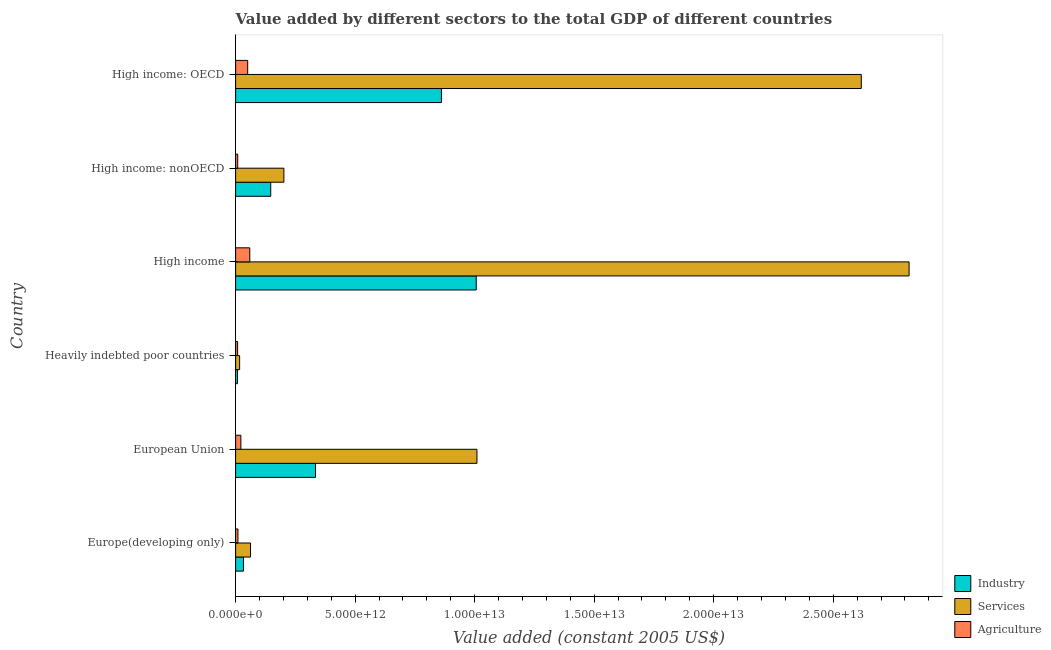How many different coloured bars are there?
Ensure brevity in your answer.  3. How many groups of bars are there?
Your answer should be very brief. 6. Are the number of bars per tick equal to the number of legend labels?
Make the answer very short. Yes. What is the label of the 5th group of bars from the top?
Keep it short and to the point. European Union. What is the value added by agricultural sector in High income: OECD?
Provide a short and direct response. 5.05e+11. Across all countries, what is the maximum value added by agricultural sector?
Ensure brevity in your answer.  5.92e+11. Across all countries, what is the minimum value added by services?
Provide a succinct answer. 1.68e+11. In which country was the value added by industrial sector minimum?
Offer a terse response. Heavily indebted poor countries. What is the total value added by agricultural sector in the graph?
Make the answer very short. 1.58e+12. What is the difference between the value added by services in European Union and that in High income: OECD?
Offer a terse response. -1.61e+13. What is the difference between the value added by industrial sector in High income and the value added by agricultural sector in European Union?
Keep it short and to the point. 9.85e+12. What is the average value added by industrial sector per country?
Give a very brief answer. 3.98e+12. What is the difference between the value added by agricultural sector and value added by services in High income?
Make the answer very short. -2.76e+13. What is the ratio of the value added by industrial sector in Heavily indebted poor countries to that in High income: nonOECD?
Ensure brevity in your answer.  0.05. Is the value added by industrial sector in European Union less than that in High income?
Offer a terse response. Yes. Is the difference between the value added by agricultural sector in Europe(developing only) and High income: nonOECD greater than the difference between the value added by industrial sector in Europe(developing only) and High income: nonOECD?
Provide a short and direct response. Yes. What is the difference between the highest and the second highest value added by agricultural sector?
Offer a very short reply. 8.76e+1. What is the difference between the highest and the lowest value added by industrial sector?
Keep it short and to the point. 9.99e+12. Is the sum of the value added by services in European Union and High income: nonOECD greater than the maximum value added by agricultural sector across all countries?
Give a very brief answer. Yes. What does the 1st bar from the top in High income: nonOECD represents?
Provide a short and direct response. Agriculture. What does the 1st bar from the bottom in High income represents?
Your response must be concise. Industry. Is it the case that in every country, the sum of the value added by industrial sector and value added by services is greater than the value added by agricultural sector?
Your response must be concise. Yes. How many bars are there?
Your response must be concise. 18. Are all the bars in the graph horizontal?
Provide a short and direct response. Yes. How many countries are there in the graph?
Your answer should be very brief. 6. What is the difference between two consecutive major ticks on the X-axis?
Ensure brevity in your answer.  5.00e+12. Are the values on the major ticks of X-axis written in scientific E-notation?
Offer a very short reply. Yes. Does the graph contain any zero values?
Keep it short and to the point. No. Does the graph contain grids?
Ensure brevity in your answer.  No. Where does the legend appear in the graph?
Ensure brevity in your answer.  Bottom right. How are the legend labels stacked?
Offer a very short reply. Vertical. What is the title of the graph?
Make the answer very short. Value added by different sectors to the total GDP of different countries. What is the label or title of the X-axis?
Keep it short and to the point. Value added (constant 2005 US$). What is the Value added (constant 2005 US$) of Industry in Europe(developing only)?
Give a very brief answer. 3.29e+11. What is the Value added (constant 2005 US$) in Services in Europe(developing only)?
Make the answer very short. 6.24e+11. What is the Value added (constant 2005 US$) of Agriculture in Europe(developing only)?
Your answer should be very brief. 9.71e+1. What is the Value added (constant 2005 US$) in Industry in European Union?
Give a very brief answer. 3.34e+12. What is the Value added (constant 2005 US$) of Services in European Union?
Ensure brevity in your answer.  1.01e+13. What is the Value added (constant 2005 US$) of Agriculture in European Union?
Your answer should be compact. 2.20e+11. What is the Value added (constant 2005 US$) in Industry in Heavily indebted poor countries?
Give a very brief answer. 7.92e+1. What is the Value added (constant 2005 US$) of Services in Heavily indebted poor countries?
Provide a short and direct response. 1.68e+11. What is the Value added (constant 2005 US$) in Agriculture in Heavily indebted poor countries?
Make the answer very short. 8.35e+1. What is the Value added (constant 2005 US$) of Industry in High income?
Ensure brevity in your answer.  1.01e+13. What is the Value added (constant 2005 US$) in Services in High income?
Offer a very short reply. 2.82e+13. What is the Value added (constant 2005 US$) of Agriculture in High income?
Give a very brief answer. 5.92e+11. What is the Value added (constant 2005 US$) in Industry in High income: nonOECD?
Your response must be concise. 1.47e+12. What is the Value added (constant 2005 US$) of Services in High income: nonOECD?
Your answer should be compact. 2.02e+12. What is the Value added (constant 2005 US$) of Agriculture in High income: nonOECD?
Offer a very short reply. 8.76e+1. What is the Value added (constant 2005 US$) in Industry in High income: OECD?
Provide a short and direct response. 8.61e+12. What is the Value added (constant 2005 US$) of Services in High income: OECD?
Give a very brief answer. 2.62e+13. What is the Value added (constant 2005 US$) of Agriculture in High income: OECD?
Your answer should be very brief. 5.05e+11. Across all countries, what is the maximum Value added (constant 2005 US$) in Industry?
Offer a terse response. 1.01e+13. Across all countries, what is the maximum Value added (constant 2005 US$) of Services?
Your response must be concise. 2.82e+13. Across all countries, what is the maximum Value added (constant 2005 US$) in Agriculture?
Provide a short and direct response. 5.92e+11. Across all countries, what is the minimum Value added (constant 2005 US$) of Industry?
Provide a succinct answer. 7.92e+1. Across all countries, what is the minimum Value added (constant 2005 US$) in Services?
Your response must be concise. 1.68e+11. Across all countries, what is the minimum Value added (constant 2005 US$) in Agriculture?
Offer a very short reply. 8.35e+1. What is the total Value added (constant 2005 US$) of Industry in the graph?
Give a very brief answer. 2.39e+13. What is the total Value added (constant 2005 US$) in Services in the graph?
Offer a terse response. 6.73e+13. What is the total Value added (constant 2005 US$) of Agriculture in the graph?
Ensure brevity in your answer.  1.58e+12. What is the difference between the Value added (constant 2005 US$) in Industry in Europe(developing only) and that in European Union?
Make the answer very short. -3.01e+12. What is the difference between the Value added (constant 2005 US$) of Services in Europe(developing only) and that in European Union?
Offer a very short reply. -9.47e+12. What is the difference between the Value added (constant 2005 US$) of Agriculture in Europe(developing only) and that in European Union?
Ensure brevity in your answer.  -1.23e+11. What is the difference between the Value added (constant 2005 US$) in Industry in Europe(developing only) and that in Heavily indebted poor countries?
Give a very brief answer. 2.49e+11. What is the difference between the Value added (constant 2005 US$) of Services in Europe(developing only) and that in Heavily indebted poor countries?
Your answer should be compact. 4.56e+11. What is the difference between the Value added (constant 2005 US$) of Agriculture in Europe(developing only) and that in Heavily indebted poor countries?
Make the answer very short. 1.36e+1. What is the difference between the Value added (constant 2005 US$) of Industry in Europe(developing only) and that in High income?
Make the answer very short. -9.74e+12. What is the difference between the Value added (constant 2005 US$) of Services in Europe(developing only) and that in High income?
Your response must be concise. -2.76e+13. What is the difference between the Value added (constant 2005 US$) in Agriculture in Europe(developing only) and that in High income?
Ensure brevity in your answer.  -4.95e+11. What is the difference between the Value added (constant 2005 US$) of Industry in Europe(developing only) and that in High income: nonOECD?
Your response must be concise. -1.14e+12. What is the difference between the Value added (constant 2005 US$) of Services in Europe(developing only) and that in High income: nonOECD?
Ensure brevity in your answer.  -1.40e+12. What is the difference between the Value added (constant 2005 US$) of Agriculture in Europe(developing only) and that in High income: nonOECD?
Offer a terse response. 9.49e+09. What is the difference between the Value added (constant 2005 US$) of Industry in Europe(developing only) and that in High income: OECD?
Provide a short and direct response. -8.28e+12. What is the difference between the Value added (constant 2005 US$) of Services in Europe(developing only) and that in High income: OECD?
Your answer should be very brief. -2.56e+13. What is the difference between the Value added (constant 2005 US$) of Agriculture in Europe(developing only) and that in High income: OECD?
Provide a short and direct response. -4.08e+11. What is the difference between the Value added (constant 2005 US$) of Industry in European Union and that in Heavily indebted poor countries?
Your answer should be very brief. 3.26e+12. What is the difference between the Value added (constant 2005 US$) in Services in European Union and that in Heavily indebted poor countries?
Offer a terse response. 9.93e+12. What is the difference between the Value added (constant 2005 US$) of Agriculture in European Union and that in Heavily indebted poor countries?
Your response must be concise. 1.36e+11. What is the difference between the Value added (constant 2005 US$) in Industry in European Union and that in High income?
Keep it short and to the point. -6.72e+12. What is the difference between the Value added (constant 2005 US$) in Services in European Union and that in High income?
Your answer should be compact. -1.81e+13. What is the difference between the Value added (constant 2005 US$) in Agriculture in European Union and that in High income?
Make the answer very short. -3.73e+11. What is the difference between the Value added (constant 2005 US$) in Industry in European Union and that in High income: nonOECD?
Make the answer very short. 1.87e+12. What is the difference between the Value added (constant 2005 US$) of Services in European Union and that in High income: nonOECD?
Offer a very short reply. 8.08e+12. What is the difference between the Value added (constant 2005 US$) in Agriculture in European Union and that in High income: nonOECD?
Make the answer very short. 1.32e+11. What is the difference between the Value added (constant 2005 US$) in Industry in European Union and that in High income: OECD?
Provide a succinct answer. -5.27e+12. What is the difference between the Value added (constant 2005 US$) of Services in European Union and that in High income: OECD?
Your answer should be compact. -1.61e+13. What is the difference between the Value added (constant 2005 US$) of Agriculture in European Union and that in High income: OECD?
Your response must be concise. -2.85e+11. What is the difference between the Value added (constant 2005 US$) of Industry in Heavily indebted poor countries and that in High income?
Provide a short and direct response. -9.99e+12. What is the difference between the Value added (constant 2005 US$) of Services in Heavily indebted poor countries and that in High income?
Your answer should be very brief. -2.80e+13. What is the difference between the Value added (constant 2005 US$) in Agriculture in Heavily indebted poor countries and that in High income?
Ensure brevity in your answer.  -5.09e+11. What is the difference between the Value added (constant 2005 US$) in Industry in Heavily indebted poor countries and that in High income: nonOECD?
Provide a succinct answer. -1.39e+12. What is the difference between the Value added (constant 2005 US$) of Services in Heavily indebted poor countries and that in High income: nonOECD?
Provide a short and direct response. -1.85e+12. What is the difference between the Value added (constant 2005 US$) in Agriculture in Heavily indebted poor countries and that in High income: nonOECD?
Your answer should be compact. -4.11e+09. What is the difference between the Value added (constant 2005 US$) of Industry in Heavily indebted poor countries and that in High income: OECD?
Your answer should be compact. -8.53e+12. What is the difference between the Value added (constant 2005 US$) in Services in Heavily indebted poor countries and that in High income: OECD?
Ensure brevity in your answer.  -2.60e+13. What is the difference between the Value added (constant 2005 US$) of Agriculture in Heavily indebted poor countries and that in High income: OECD?
Your answer should be very brief. -4.21e+11. What is the difference between the Value added (constant 2005 US$) in Industry in High income and that in High income: nonOECD?
Make the answer very short. 8.60e+12. What is the difference between the Value added (constant 2005 US$) of Services in High income and that in High income: nonOECD?
Offer a terse response. 2.62e+13. What is the difference between the Value added (constant 2005 US$) of Agriculture in High income and that in High income: nonOECD?
Offer a terse response. 5.05e+11. What is the difference between the Value added (constant 2005 US$) in Industry in High income and that in High income: OECD?
Provide a short and direct response. 1.46e+12. What is the difference between the Value added (constant 2005 US$) of Services in High income and that in High income: OECD?
Your response must be concise. 2.00e+12. What is the difference between the Value added (constant 2005 US$) of Agriculture in High income and that in High income: OECD?
Provide a short and direct response. 8.76e+1. What is the difference between the Value added (constant 2005 US$) of Industry in High income: nonOECD and that in High income: OECD?
Provide a short and direct response. -7.14e+12. What is the difference between the Value added (constant 2005 US$) in Services in High income: nonOECD and that in High income: OECD?
Your answer should be very brief. -2.42e+13. What is the difference between the Value added (constant 2005 US$) in Agriculture in High income: nonOECD and that in High income: OECD?
Make the answer very short. -4.17e+11. What is the difference between the Value added (constant 2005 US$) of Industry in Europe(developing only) and the Value added (constant 2005 US$) of Services in European Union?
Provide a succinct answer. -9.77e+12. What is the difference between the Value added (constant 2005 US$) of Industry in Europe(developing only) and the Value added (constant 2005 US$) of Agriculture in European Union?
Ensure brevity in your answer.  1.09e+11. What is the difference between the Value added (constant 2005 US$) of Services in Europe(developing only) and the Value added (constant 2005 US$) of Agriculture in European Union?
Your answer should be very brief. 4.04e+11. What is the difference between the Value added (constant 2005 US$) of Industry in Europe(developing only) and the Value added (constant 2005 US$) of Services in Heavily indebted poor countries?
Your answer should be compact. 1.61e+11. What is the difference between the Value added (constant 2005 US$) in Industry in Europe(developing only) and the Value added (constant 2005 US$) in Agriculture in Heavily indebted poor countries?
Give a very brief answer. 2.45e+11. What is the difference between the Value added (constant 2005 US$) of Services in Europe(developing only) and the Value added (constant 2005 US$) of Agriculture in Heavily indebted poor countries?
Your response must be concise. 5.41e+11. What is the difference between the Value added (constant 2005 US$) of Industry in Europe(developing only) and the Value added (constant 2005 US$) of Services in High income?
Ensure brevity in your answer.  -2.78e+13. What is the difference between the Value added (constant 2005 US$) of Industry in Europe(developing only) and the Value added (constant 2005 US$) of Agriculture in High income?
Your answer should be compact. -2.64e+11. What is the difference between the Value added (constant 2005 US$) of Services in Europe(developing only) and the Value added (constant 2005 US$) of Agriculture in High income?
Your answer should be very brief. 3.18e+1. What is the difference between the Value added (constant 2005 US$) of Industry in Europe(developing only) and the Value added (constant 2005 US$) of Services in High income: nonOECD?
Offer a very short reply. -1.69e+12. What is the difference between the Value added (constant 2005 US$) in Industry in Europe(developing only) and the Value added (constant 2005 US$) in Agriculture in High income: nonOECD?
Make the answer very short. 2.41e+11. What is the difference between the Value added (constant 2005 US$) of Services in Europe(developing only) and the Value added (constant 2005 US$) of Agriculture in High income: nonOECD?
Your response must be concise. 5.36e+11. What is the difference between the Value added (constant 2005 US$) in Industry in Europe(developing only) and the Value added (constant 2005 US$) in Services in High income: OECD?
Provide a short and direct response. -2.58e+13. What is the difference between the Value added (constant 2005 US$) in Industry in Europe(developing only) and the Value added (constant 2005 US$) in Agriculture in High income: OECD?
Provide a succinct answer. -1.76e+11. What is the difference between the Value added (constant 2005 US$) of Services in Europe(developing only) and the Value added (constant 2005 US$) of Agriculture in High income: OECD?
Ensure brevity in your answer.  1.19e+11. What is the difference between the Value added (constant 2005 US$) of Industry in European Union and the Value added (constant 2005 US$) of Services in Heavily indebted poor countries?
Provide a succinct answer. 3.17e+12. What is the difference between the Value added (constant 2005 US$) of Industry in European Union and the Value added (constant 2005 US$) of Agriculture in Heavily indebted poor countries?
Provide a short and direct response. 3.26e+12. What is the difference between the Value added (constant 2005 US$) in Services in European Union and the Value added (constant 2005 US$) in Agriculture in Heavily indebted poor countries?
Give a very brief answer. 1.00e+13. What is the difference between the Value added (constant 2005 US$) of Industry in European Union and the Value added (constant 2005 US$) of Services in High income?
Your response must be concise. -2.48e+13. What is the difference between the Value added (constant 2005 US$) in Industry in European Union and the Value added (constant 2005 US$) in Agriculture in High income?
Keep it short and to the point. 2.75e+12. What is the difference between the Value added (constant 2005 US$) of Services in European Union and the Value added (constant 2005 US$) of Agriculture in High income?
Offer a very short reply. 9.50e+12. What is the difference between the Value added (constant 2005 US$) of Industry in European Union and the Value added (constant 2005 US$) of Services in High income: nonOECD?
Offer a terse response. 1.32e+12. What is the difference between the Value added (constant 2005 US$) in Industry in European Union and the Value added (constant 2005 US$) in Agriculture in High income: nonOECD?
Ensure brevity in your answer.  3.26e+12. What is the difference between the Value added (constant 2005 US$) in Services in European Union and the Value added (constant 2005 US$) in Agriculture in High income: nonOECD?
Give a very brief answer. 1.00e+13. What is the difference between the Value added (constant 2005 US$) of Industry in European Union and the Value added (constant 2005 US$) of Services in High income: OECD?
Give a very brief answer. -2.28e+13. What is the difference between the Value added (constant 2005 US$) of Industry in European Union and the Value added (constant 2005 US$) of Agriculture in High income: OECD?
Offer a terse response. 2.84e+12. What is the difference between the Value added (constant 2005 US$) in Services in European Union and the Value added (constant 2005 US$) in Agriculture in High income: OECD?
Keep it short and to the point. 9.59e+12. What is the difference between the Value added (constant 2005 US$) of Industry in Heavily indebted poor countries and the Value added (constant 2005 US$) of Services in High income?
Your answer should be very brief. -2.81e+13. What is the difference between the Value added (constant 2005 US$) of Industry in Heavily indebted poor countries and the Value added (constant 2005 US$) of Agriculture in High income?
Keep it short and to the point. -5.13e+11. What is the difference between the Value added (constant 2005 US$) of Services in Heavily indebted poor countries and the Value added (constant 2005 US$) of Agriculture in High income?
Make the answer very short. -4.24e+11. What is the difference between the Value added (constant 2005 US$) in Industry in Heavily indebted poor countries and the Value added (constant 2005 US$) in Services in High income: nonOECD?
Your answer should be very brief. -1.94e+12. What is the difference between the Value added (constant 2005 US$) of Industry in Heavily indebted poor countries and the Value added (constant 2005 US$) of Agriculture in High income: nonOECD?
Keep it short and to the point. -8.33e+09. What is the difference between the Value added (constant 2005 US$) of Services in Heavily indebted poor countries and the Value added (constant 2005 US$) of Agriculture in High income: nonOECD?
Give a very brief answer. 8.03e+1. What is the difference between the Value added (constant 2005 US$) of Industry in Heavily indebted poor countries and the Value added (constant 2005 US$) of Services in High income: OECD?
Offer a terse response. -2.61e+13. What is the difference between the Value added (constant 2005 US$) in Industry in Heavily indebted poor countries and the Value added (constant 2005 US$) in Agriculture in High income: OECD?
Ensure brevity in your answer.  -4.25e+11. What is the difference between the Value added (constant 2005 US$) in Services in Heavily indebted poor countries and the Value added (constant 2005 US$) in Agriculture in High income: OECD?
Your answer should be compact. -3.37e+11. What is the difference between the Value added (constant 2005 US$) in Industry in High income and the Value added (constant 2005 US$) in Services in High income: nonOECD?
Provide a succinct answer. 8.05e+12. What is the difference between the Value added (constant 2005 US$) of Industry in High income and the Value added (constant 2005 US$) of Agriculture in High income: nonOECD?
Your answer should be compact. 9.98e+12. What is the difference between the Value added (constant 2005 US$) of Services in High income and the Value added (constant 2005 US$) of Agriculture in High income: nonOECD?
Keep it short and to the point. 2.81e+13. What is the difference between the Value added (constant 2005 US$) of Industry in High income and the Value added (constant 2005 US$) of Services in High income: OECD?
Keep it short and to the point. -1.61e+13. What is the difference between the Value added (constant 2005 US$) of Industry in High income and the Value added (constant 2005 US$) of Agriculture in High income: OECD?
Provide a short and direct response. 9.56e+12. What is the difference between the Value added (constant 2005 US$) in Services in High income and the Value added (constant 2005 US$) in Agriculture in High income: OECD?
Make the answer very short. 2.77e+13. What is the difference between the Value added (constant 2005 US$) of Industry in High income: nonOECD and the Value added (constant 2005 US$) of Services in High income: OECD?
Give a very brief answer. -2.47e+13. What is the difference between the Value added (constant 2005 US$) of Industry in High income: nonOECD and the Value added (constant 2005 US$) of Agriculture in High income: OECD?
Ensure brevity in your answer.  9.64e+11. What is the difference between the Value added (constant 2005 US$) in Services in High income: nonOECD and the Value added (constant 2005 US$) in Agriculture in High income: OECD?
Ensure brevity in your answer.  1.51e+12. What is the average Value added (constant 2005 US$) of Industry per country?
Give a very brief answer. 3.98e+12. What is the average Value added (constant 2005 US$) of Services per country?
Ensure brevity in your answer.  1.12e+13. What is the average Value added (constant 2005 US$) of Agriculture per country?
Make the answer very short. 2.64e+11. What is the difference between the Value added (constant 2005 US$) in Industry and Value added (constant 2005 US$) in Services in Europe(developing only)?
Ensure brevity in your answer.  -2.95e+11. What is the difference between the Value added (constant 2005 US$) in Industry and Value added (constant 2005 US$) in Agriculture in Europe(developing only)?
Provide a succinct answer. 2.32e+11. What is the difference between the Value added (constant 2005 US$) in Services and Value added (constant 2005 US$) in Agriculture in Europe(developing only)?
Keep it short and to the point. 5.27e+11. What is the difference between the Value added (constant 2005 US$) of Industry and Value added (constant 2005 US$) of Services in European Union?
Your answer should be very brief. -6.75e+12. What is the difference between the Value added (constant 2005 US$) of Industry and Value added (constant 2005 US$) of Agriculture in European Union?
Offer a very short reply. 3.12e+12. What is the difference between the Value added (constant 2005 US$) in Services and Value added (constant 2005 US$) in Agriculture in European Union?
Your answer should be very brief. 9.88e+12. What is the difference between the Value added (constant 2005 US$) in Industry and Value added (constant 2005 US$) in Services in Heavily indebted poor countries?
Your answer should be compact. -8.87e+1. What is the difference between the Value added (constant 2005 US$) of Industry and Value added (constant 2005 US$) of Agriculture in Heavily indebted poor countries?
Offer a very short reply. -4.22e+09. What is the difference between the Value added (constant 2005 US$) in Services and Value added (constant 2005 US$) in Agriculture in Heavily indebted poor countries?
Make the answer very short. 8.44e+1. What is the difference between the Value added (constant 2005 US$) in Industry and Value added (constant 2005 US$) in Services in High income?
Provide a succinct answer. -1.81e+13. What is the difference between the Value added (constant 2005 US$) of Industry and Value added (constant 2005 US$) of Agriculture in High income?
Your answer should be very brief. 9.47e+12. What is the difference between the Value added (constant 2005 US$) of Services and Value added (constant 2005 US$) of Agriculture in High income?
Make the answer very short. 2.76e+13. What is the difference between the Value added (constant 2005 US$) of Industry and Value added (constant 2005 US$) of Services in High income: nonOECD?
Ensure brevity in your answer.  -5.50e+11. What is the difference between the Value added (constant 2005 US$) of Industry and Value added (constant 2005 US$) of Agriculture in High income: nonOECD?
Offer a very short reply. 1.38e+12. What is the difference between the Value added (constant 2005 US$) of Services and Value added (constant 2005 US$) of Agriculture in High income: nonOECD?
Offer a terse response. 1.93e+12. What is the difference between the Value added (constant 2005 US$) of Industry and Value added (constant 2005 US$) of Services in High income: OECD?
Your answer should be compact. -1.76e+13. What is the difference between the Value added (constant 2005 US$) of Industry and Value added (constant 2005 US$) of Agriculture in High income: OECD?
Your answer should be compact. 8.10e+12. What is the difference between the Value added (constant 2005 US$) in Services and Value added (constant 2005 US$) in Agriculture in High income: OECD?
Your answer should be compact. 2.57e+13. What is the ratio of the Value added (constant 2005 US$) in Industry in Europe(developing only) to that in European Union?
Offer a very short reply. 0.1. What is the ratio of the Value added (constant 2005 US$) of Services in Europe(developing only) to that in European Union?
Provide a short and direct response. 0.06. What is the ratio of the Value added (constant 2005 US$) of Agriculture in Europe(developing only) to that in European Union?
Offer a terse response. 0.44. What is the ratio of the Value added (constant 2005 US$) in Industry in Europe(developing only) to that in Heavily indebted poor countries?
Offer a terse response. 4.15. What is the ratio of the Value added (constant 2005 US$) in Services in Europe(developing only) to that in Heavily indebted poor countries?
Give a very brief answer. 3.72. What is the ratio of the Value added (constant 2005 US$) in Agriculture in Europe(developing only) to that in Heavily indebted poor countries?
Your answer should be compact. 1.16. What is the ratio of the Value added (constant 2005 US$) of Industry in Europe(developing only) to that in High income?
Give a very brief answer. 0.03. What is the ratio of the Value added (constant 2005 US$) in Services in Europe(developing only) to that in High income?
Keep it short and to the point. 0.02. What is the ratio of the Value added (constant 2005 US$) in Agriculture in Europe(developing only) to that in High income?
Ensure brevity in your answer.  0.16. What is the ratio of the Value added (constant 2005 US$) of Industry in Europe(developing only) to that in High income: nonOECD?
Give a very brief answer. 0.22. What is the ratio of the Value added (constant 2005 US$) in Services in Europe(developing only) to that in High income: nonOECD?
Make the answer very short. 0.31. What is the ratio of the Value added (constant 2005 US$) of Agriculture in Europe(developing only) to that in High income: nonOECD?
Your answer should be very brief. 1.11. What is the ratio of the Value added (constant 2005 US$) in Industry in Europe(developing only) to that in High income: OECD?
Offer a terse response. 0.04. What is the ratio of the Value added (constant 2005 US$) of Services in Europe(developing only) to that in High income: OECD?
Give a very brief answer. 0.02. What is the ratio of the Value added (constant 2005 US$) of Agriculture in Europe(developing only) to that in High income: OECD?
Offer a very short reply. 0.19. What is the ratio of the Value added (constant 2005 US$) of Industry in European Union to that in Heavily indebted poor countries?
Give a very brief answer. 42.18. What is the ratio of the Value added (constant 2005 US$) in Services in European Union to that in Heavily indebted poor countries?
Provide a succinct answer. 60.13. What is the ratio of the Value added (constant 2005 US$) in Agriculture in European Union to that in Heavily indebted poor countries?
Provide a succinct answer. 2.63. What is the ratio of the Value added (constant 2005 US$) of Industry in European Union to that in High income?
Provide a succinct answer. 0.33. What is the ratio of the Value added (constant 2005 US$) in Services in European Union to that in High income?
Your answer should be very brief. 0.36. What is the ratio of the Value added (constant 2005 US$) in Agriculture in European Union to that in High income?
Offer a very short reply. 0.37. What is the ratio of the Value added (constant 2005 US$) in Industry in European Union to that in High income: nonOECD?
Offer a terse response. 2.28. What is the ratio of the Value added (constant 2005 US$) in Services in European Union to that in High income: nonOECD?
Your answer should be compact. 5. What is the ratio of the Value added (constant 2005 US$) in Agriculture in European Union to that in High income: nonOECD?
Your answer should be compact. 2.51. What is the ratio of the Value added (constant 2005 US$) of Industry in European Union to that in High income: OECD?
Offer a terse response. 0.39. What is the ratio of the Value added (constant 2005 US$) in Services in European Union to that in High income: OECD?
Your response must be concise. 0.39. What is the ratio of the Value added (constant 2005 US$) in Agriculture in European Union to that in High income: OECD?
Provide a succinct answer. 0.44. What is the ratio of the Value added (constant 2005 US$) of Industry in Heavily indebted poor countries to that in High income?
Give a very brief answer. 0.01. What is the ratio of the Value added (constant 2005 US$) in Services in Heavily indebted poor countries to that in High income?
Offer a very short reply. 0.01. What is the ratio of the Value added (constant 2005 US$) of Agriculture in Heavily indebted poor countries to that in High income?
Give a very brief answer. 0.14. What is the ratio of the Value added (constant 2005 US$) in Industry in Heavily indebted poor countries to that in High income: nonOECD?
Make the answer very short. 0.05. What is the ratio of the Value added (constant 2005 US$) of Services in Heavily indebted poor countries to that in High income: nonOECD?
Make the answer very short. 0.08. What is the ratio of the Value added (constant 2005 US$) in Agriculture in Heavily indebted poor countries to that in High income: nonOECD?
Make the answer very short. 0.95. What is the ratio of the Value added (constant 2005 US$) in Industry in Heavily indebted poor countries to that in High income: OECD?
Make the answer very short. 0.01. What is the ratio of the Value added (constant 2005 US$) in Services in Heavily indebted poor countries to that in High income: OECD?
Give a very brief answer. 0.01. What is the ratio of the Value added (constant 2005 US$) in Agriculture in Heavily indebted poor countries to that in High income: OECD?
Provide a succinct answer. 0.17. What is the ratio of the Value added (constant 2005 US$) of Industry in High income to that in High income: nonOECD?
Make the answer very short. 6.85. What is the ratio of the Value added (constant 2005 US$) of Services in High income to that in High income: nonOECD?
Give a very brief answer. 13.95. What is the ratio of the Value added (constant 2005 US$) of Agriculture in High income to that in High income: nonOECD?
Your response must be concise. 6.76. What is the ratio of the Value added (constant 2005 US$) of Industry in High income to that in High income: OECD?
Your answer should be compact. 1.17. What is the ratio of the Value added (constant 2005 US$) in Services in High income to that in High income: OECD?
Provide a short and direct response. 1.08. What is the ratio of the Value added (constant 2005 US$) of Agriculture in High income to that in High income: OECD?
Give a very brief answer. 1.17. What is the ratio of the Value added (constant 2005 US$) in Industry in High income: nonOECD to that in High income: OECD?
Ensure brevity in your answer.  0.17. What is the ratio of the Value added (constant 2005 US$) of Services in High income: nonOECD to that in High income: OECD?
Provide a succinct answer. 0.08. What is the ratio of the Value added (constant 2005 US$) in Agriculture in High income: nonOECD to that in High income: OECD?
Provide a succinct answer. 0.17. What is the difference between the highest and the second highest Value added (constant 2005 US$) in Industry?
Ensure brevity in your answer.  1.46e+12. What is the difference between the highest and the second highest Value added (constant 2005 US$) in Services?
Ensure brevity in your answer.  2.00e+12. What is the difference between the highest and the second highest Value added (constant 2005 US$) in Agriculture?
Offer a very short reply. 8.76e+1. What is the difference between the highest and the lowest Value added (constant 2005 US$) in Industry?
Your answer should be very brief. 9.99e+12. What is the difference between the highest and the lowest Value added (constant 2005 US$) in Services?
Provide a succinct answer. 2.80e+13. What is the difference between the highest and the lowest Value added (constant 2005 US$) of Agriculture?
Your response must be concise. 5.09e+11. 